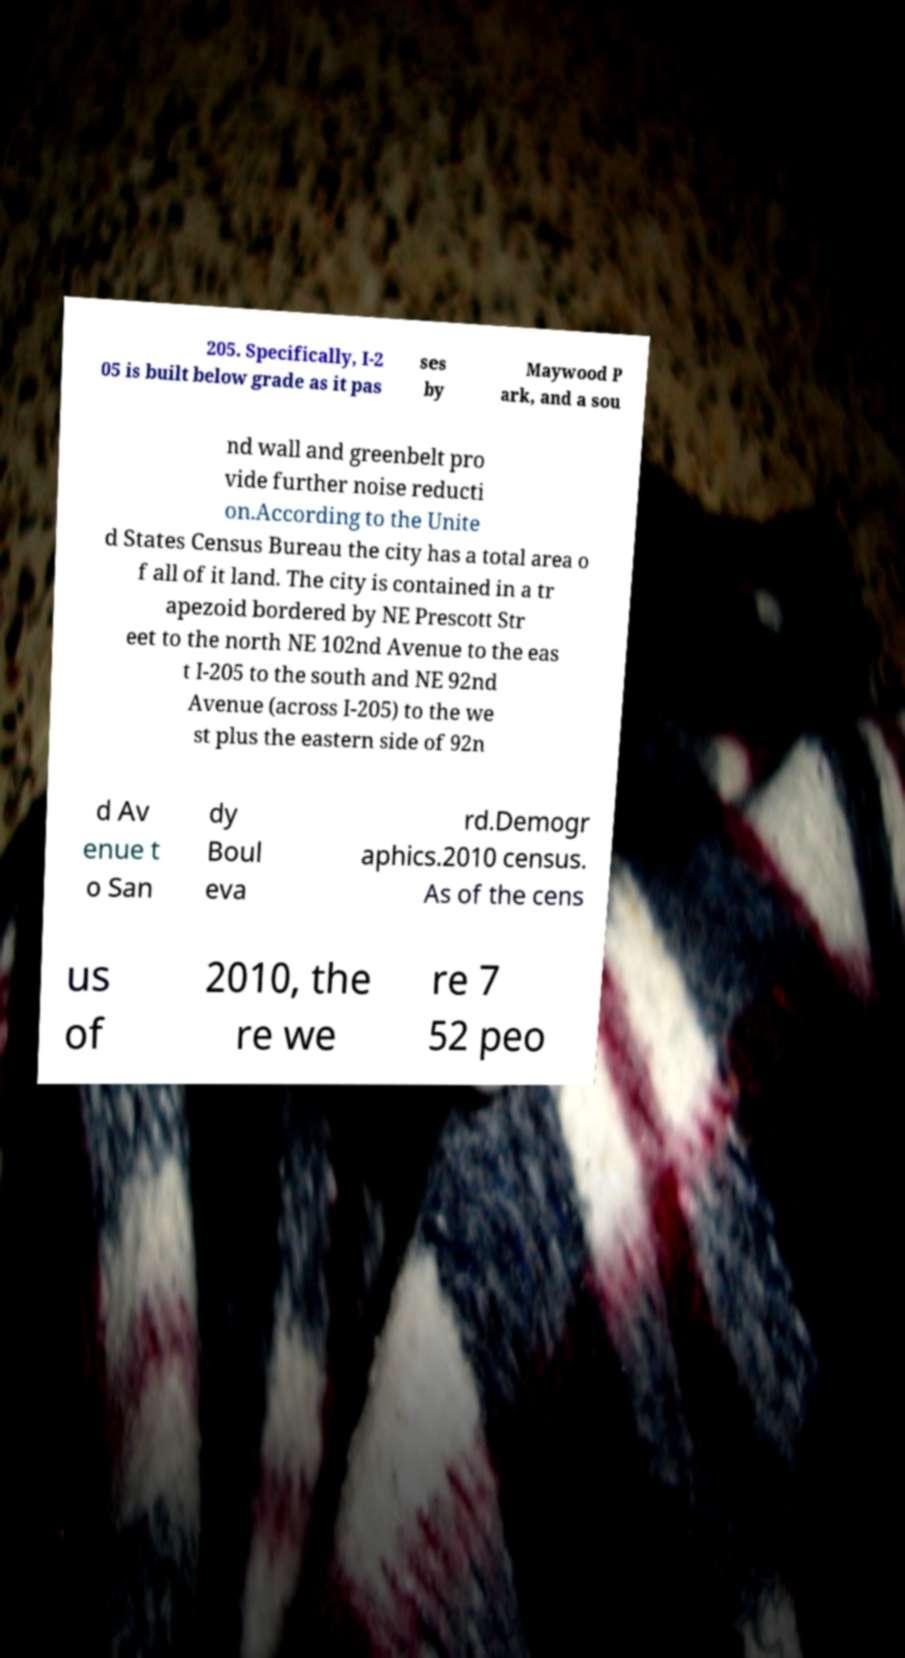Please read and relay the text visible in this image. What does it say? 205. Specifically, I-2 05 is built below grade as it pas ses by Maywood P ark, and a sou nd wall and greenbelt pro vide further noise reducti on.According to the Unite d States Census Bureau the city has a total area o f all of it land. The city is contained in a tr apezoid bordered by NE Prescott Str eet to the north NE 102nd Avenue to the eas t I-205 to the south and NE 92nd Avenue (across I-205) to the we st plus the eastern side of 92n d Av enue t o San dy Boul eva rd.Demogr aphics.2010 census. As of the cens us of 2010, the re we re 7 52 peo 